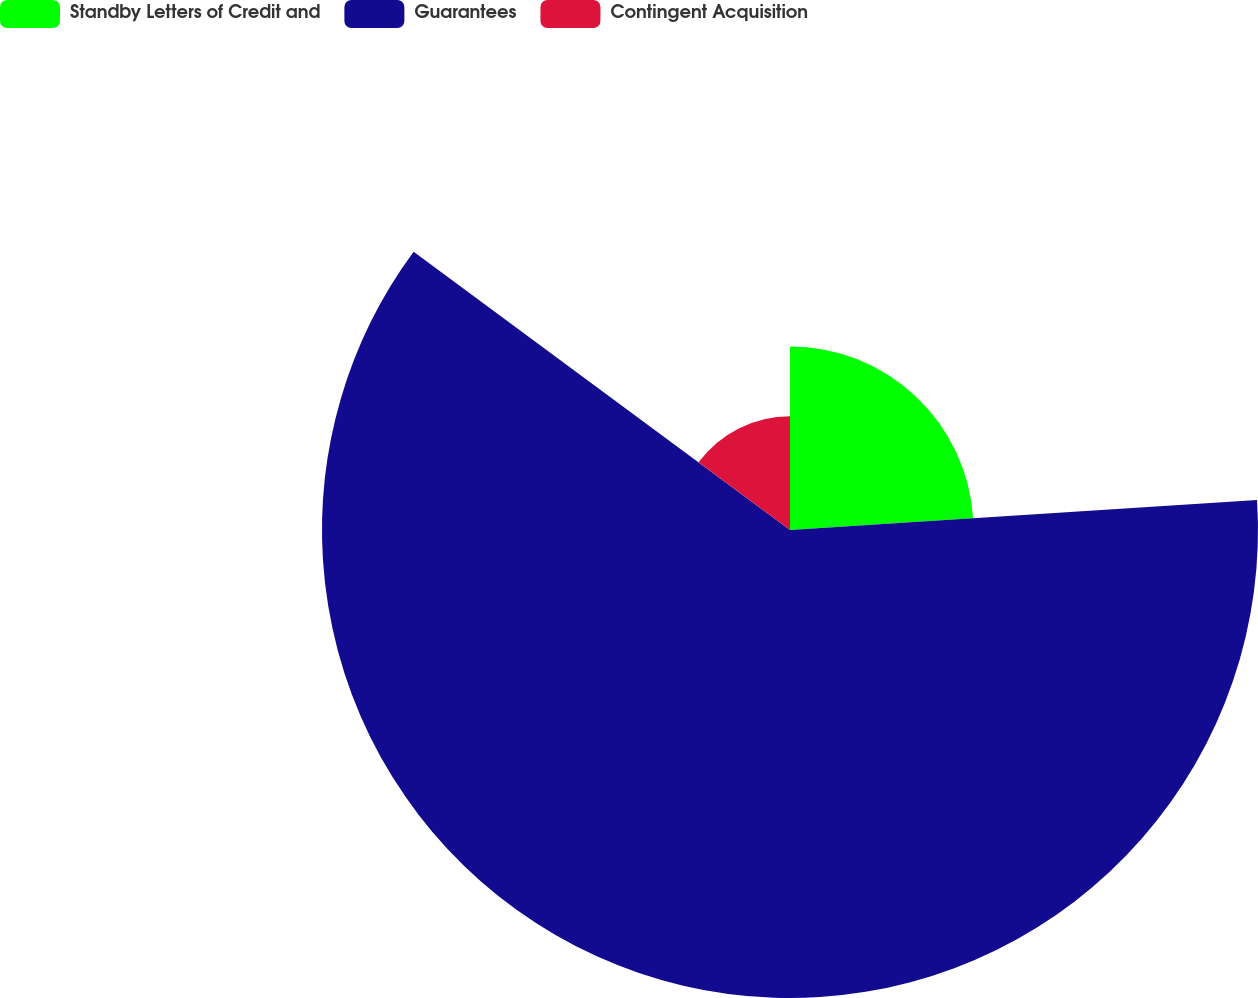Convert chart. <chart><loc_0><loc_0><loc_500><loc_500><pie_chart><fcel>Standby Letters of Credit and<fcel>Guarantees<fcel>Contingent Acquisition<nl><fcel>23.98%<fcel>61.15%<fcel>14.87%<nl></chart> 